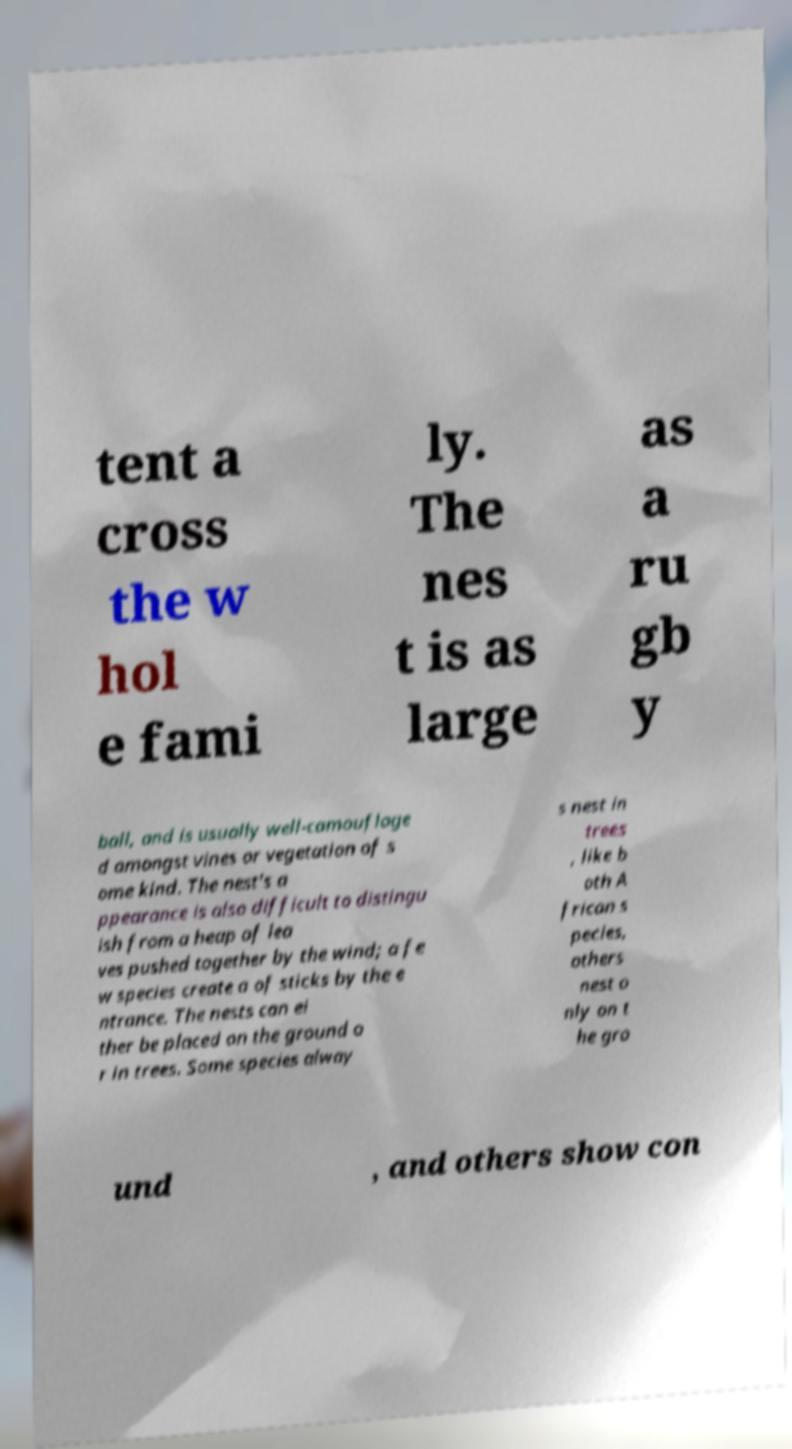I need the written content from this picture converted into text. Can you do that? tent a cross the w hol e fami ly. The nes t is as large as a ru gb y ball, and is usually well-camouflage d amongst vines or vegetation of s ome kind. The nest's a ppearance is also difficult to distingu ish from a heap of lea ves pushed together by the wind; a fe w species create a of sticks by the e ntrance. The nests can ei ther be placed on the ground o r in trees. Some species alway s nest in trees , like b oth A frican s pecies, others nest o nly on t he gro und , and others show con 